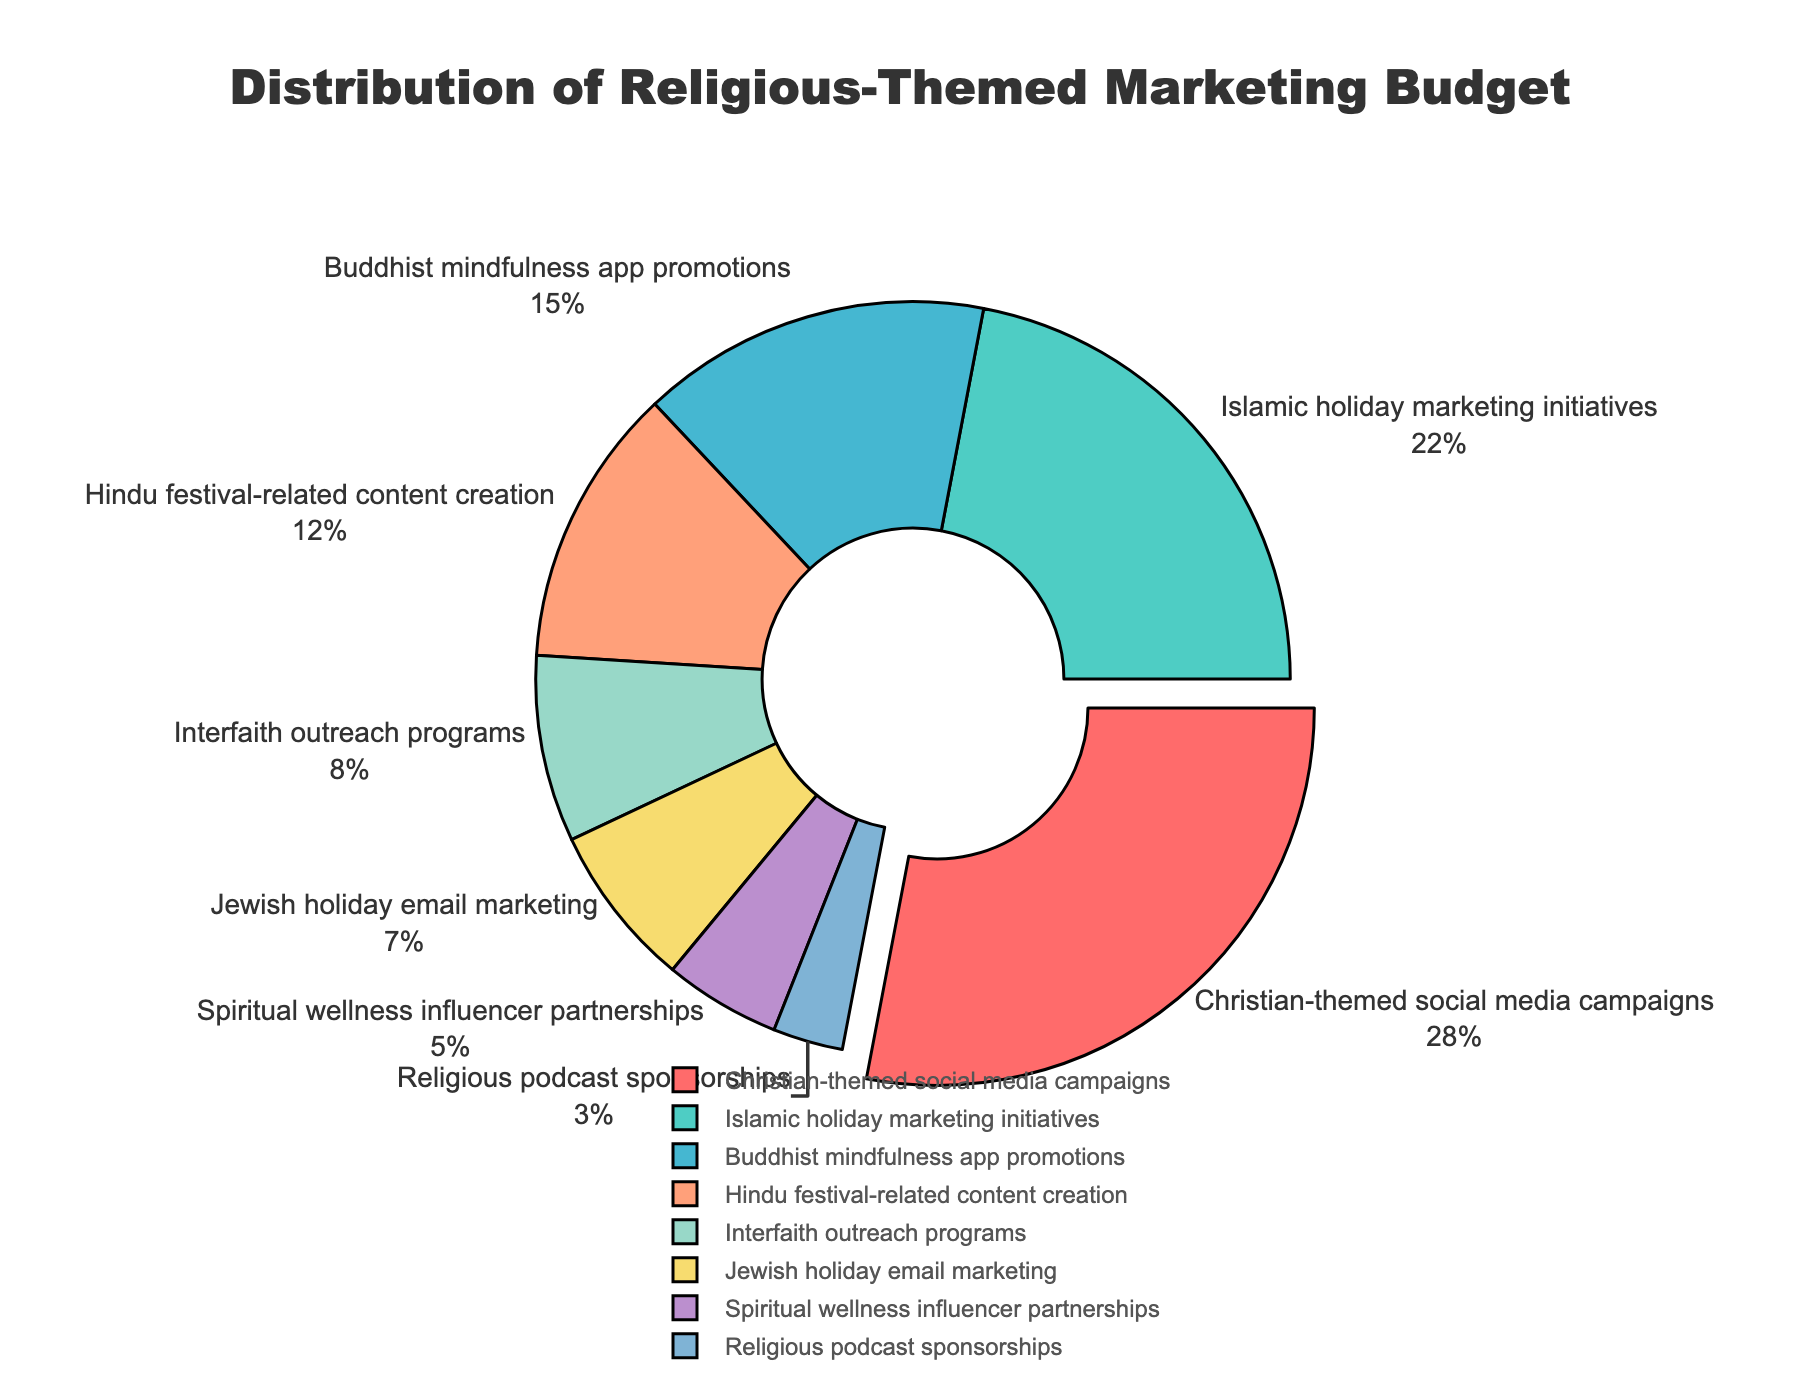What percentage of the budget is allocated to Christian-themed social media campaigns? The section labeled "Christian-themed social media campaigns" occupies 28% of the pie chart.
Answer: 28% Which two categories have the smallest budget allocations, and what are the combined percentages for these categories? The smallest allocations are for "Spiritual wellness influencer partnerships" and "Religious podcast sponsorships" with 5% and 3% respectively. Summing these gives 5% + 3% = 8%.
Answer: 8% How does the budget allocation for Islamic holiday marketing initiatives compare to that for Buddhist mindfulness app promotions? The Islamic holiday marketing initiatives have a 22% allocation while Buddhist mindfulness app promotions have 15%. The former is greater than the latter by 22% - 15% = 7%.
Answer: 7% What is the total percentage of the budget allocated to Hindu festival-related content creation and Interfaith outreach programs combined? The allocations are 12% for Hindu festival-related content creation and 8% for Interfaith outreach programs. Adding them together is 12% + 8% = 20%.
Answer: 20% Identify the section that has been pulled out slightly from the rest of the pie chart and state its budget percentage. The Christian-themed social media campaigns section is pulled out slightly and it has a 28% budget allocation.
Answer: 28% Compare the budget allocation of Jewish holiday email marketing to Interfaith outreach programs. Which one has a higher allocation and by how much? Jewish holiday email marketing has a 7% allocation, whereas Interfaith outreach programs have 8%. Interfaith outreach programs have 1% more allocation.
Answer: 1% Which category corresponds to the light cyan color, and what is its budget allocation percentage? The light cyan color corresponds to the Islamic holiday marketing initiatives category, which has a 22% allocation.
Answer: 22% What are the visual attributes (color and position) of the Buddhist mindfulness app promotions segment in the pie chart? The Buddhist mindfulness app promotions segment is depicted in blue color and positioned in the third clockwise slot from the top.
Answer: Blue, third What is the combined percentage of the budget for religious podcast sponsorships, spiritual wellness influencer partnerships, and Jewish holiday email marketing? The combined budget for these categories is calculated by adding 3% + 5% + 7% = 15%.
Answer: 15% Which category has the second-highest budget allocation, and what percentage is it? The Islamic holiday marketing initiatives category has the second-highest allocation with 22% of the budget.
Answer: 22% 